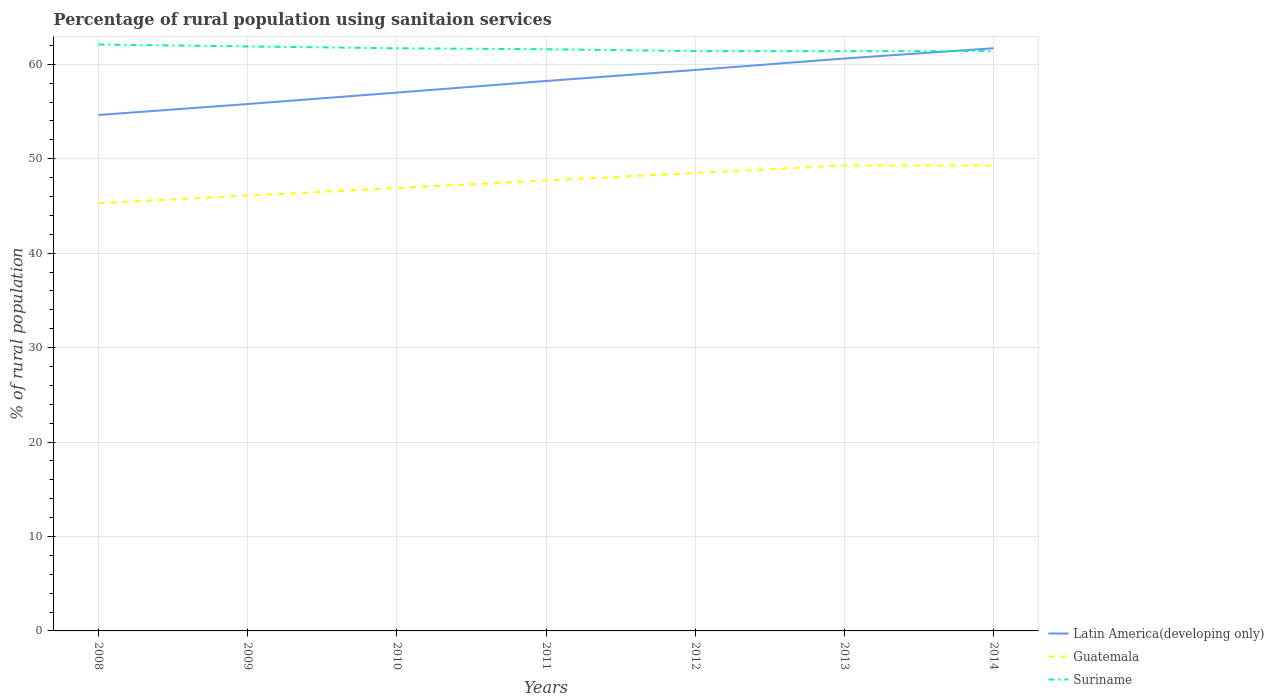How many different coloured lines are there?
Make the answer very short. 3. Does the line corresponding to Guatemala intersect with the line corresponding to Latin America(developing only)?
Offer a terse response. No. Is the number of lines equal to the number of legend labels?
Your response must be concise. Yes. Across all years, what is the maximum percentage of rural population using sanitaion services in Latin America(developing only)?
Offer a very short reply. 54.64. In which year was the percentage of rural population using sanitaion services in Guatemala maximum?
Make the answer very short. 2008. What is the total percentage of rural population using sanitaion services in Latin America(developing only) in the graph?
Make the answer very short. -7.07. What is the difference between the highest and the second highest percentage of rural population using sanitaion services in Suriname?
Provide a succinct answer. 0.7. What is the difference between the highest and the lowest percentage of rural population using sanitaion services in Suriname?
Your response must be concise. 3. Is the percentage of rural population using sanitaion services in Guatemala strictly greater than the percentage of rural population using sanitaion services in Latin America(developing only) over the years?
Your response must be concise. Yes. How many lines are there?
Offer a terse response. 3. How many years are there in the graph?
Make the answer very short. 7. What is the difference between two consecutive major ticks on the Y-axis?
Provide a short and direct response. 10. Does the graph contain any zero values?
Provide a short and direct response. No. Does the graph contain grids?
Make the answer very short. Yes. Where does the legend appear in the graph?
Your response must be concise. Bottom right. What is the title of the graph?
Provide a short and direct response. Percentage of rural population using sanitaion services. What is the label or title of the Y-axis?
Provide a short and direct response. % of rural population. What is the % of rural population of Latin America(developing only) in 2008?
Your answer should be very brief. 54.64. What is the % of rural population of Guatemala in 2008?
Your answer should be very brief. 45.3. What is the % of rural population in Suriname in 2008?
Offer a very short reply. 62.1. What is the % of rural population in Latin America(developing only) in 2009?
Provide a short and direct response. 55.8. What is the % of rural population in Guatemala in 2009?
Make the answer very short. 46.1. What is the % of rural population of Suriname in 2009?
Ensure brevity in your answer.  61.9. What is the % of rural population in Latin America(developing only) in 2010?
Ensure brevity in your answer.  57.01. What is the % of rural population in Guatemala in 2010?
Keep it short and to the point. 46.9. What is the % of rural population in Suriname in 2010?
Ensure brevity in your answer.  61.7. What is the % of rural population in Latin America(developing only) in 2011?
Your answer should be very brief. 58.24. What is the % of rural population of Guatemala in 2011?
Provide a succinct answer. 47.7. What is the % of rural population in Suriname in 2011?
Provide a succinct answer. 61.6. What is the % of rural population of Latin America(developing only) in 2012?
Provide a succinct answer. 59.4. What is the % of rural population of Guatemala in 2012?
Provide a short and direct response. 48.5. What is the % of rural population in Suriname in 2012?
Offer a terse response. 61.4. What is the % of rural population in Latin America(developing only) in 2013?
Keep it short and to the point. 60.62. What is the % of rural population of Guatemala in 2013?
Give a very brief answer. 49.3. What is the % of rural population in Suriname in 2013?
Keep it short and to the point. 61.4. What is the % of rural population in Latin America(developing only) in 2014?
Your answer should be compact. 61.7. What is the % of rural population in Guatemala in 2014?
Your answer should be compact. 49.3. What is the % of rural population of Suriname in 2014?
Your answer should be compact. 61.4. Across all years, what is the maximum % of rural population of Latin America(developing only)?
Provide a short and direct response. 61.7. Across all years, what is the maximum % of rural population in Guatemala?
Your response must be concise. 49.3. Across all years, what is the maximum % of rural population of Suriname?
Your answer should be very brief. 62.1. Across all years, what is the minimum % of rural population of Latin America(developing only)?
Offer a terse response. 54.64. Across all years, what is the minimum % of rural population of Guatemala?
Ensure brevity in your answer.  45.3. Across all years, what is the minimum % of rural population of Suriname?
Keep it short and to the point. 61.4. What is the total % of rural population of Latin America(developing only) in the graph?
Your answer should be very brief. 407.4. What is the total % of rural population in Guatemala in the graph?
Keep it short and to the point. 333.1. What is the total % of rural population in Suriname in the graph?
Offer a terse response. 431.5. What is the difference between the % of rural population of Latin America(developing only) in 2008 and that in 2009?
Ensure brevity in your answer.  -1.16. What is the difference between the % of rural population in Latin America(developing only) in 2008 and that in 2010?
Provide a short and direct response. -2.37. What is the difference between the % of rural population in Suriname in 2008 and that in 2010?
Offer a very short reply. 0.4. What is the difference between the % of rural population of Latin America(developing only) in 2008 and that in 2011?
Your response must be concise. -3.6. What is the difference between the % of rural population of Suriname in 2008 and that in 2011?
Make the answer very short. 0.5. What is the difference between the % of rural population in Latin America(developing only) in 2008 and that in 2012?
Provide a short and direct response. -4.76. What is the difference between the % of rural population of Guatemala in 2008 and that in 2012?
Keep it short and to the point. -3.2. What is the difference between the % of rural population of Latin America(developing only) in 2008 and that in 2013?
Provide a short and direct response. -5.98. What is the difference between the % of rural population of Guatemala in 2008 and that in 2013?
Your response must be concise. -4. What is the difference between the % of rural population of Latin America(developing only) in 2008 and that in 2014?
Provide a succinct answer. -7.07. What is the difference between the % of rural population in Guatemala in 2008 and that in 2014?
Make the answer very short. -4. What is the difference between the % of rural population of Suriname in 2008 and that in 2014?
Offer a terse response. 0.7. What is the difference between the % of rural population of Latin America(developing only) in 2009 and that in 2010?
Offer a very short reply. -1.21. What is the difference between the % of rural population in Latin America(developing only) in 2009 and that in 2011?
Make the answer very short. -2.44. What is the difference between the % of rural population of Guatemala in 2009 and that in 2011?
Your answer should be very brief. -1.6. What is the difference between the % of rural population of Latin America(developing only) in 2009 and that in 2012?
Your answer should be compact. -3.6. What is the difference between the % of rural population in Guatemala in 2009 and that in 2012?
Give a very brief answer. -2.4. What is the difference between the % of rural population of Latin America(developing only) in 2009 and that in 2013?
Your response must be concise. -4.82. What is the difference between the % of rural population in Suriname in 2009 and that in 2013?
Offer a very short reply. 0.5. What is the difference between the % of rural population in Latin America(developing only) in 2009 and that in 2014?
Provide a short and direct response. -5.91. What is the difference between the % of rural population in Guatemala in 2009 and that in 2014?
Keep it short and to the point. -3.2. What is the difference between the % of rural population of Suriname in 2009 and that in 2014?
Ensure brevity in your answer.  0.5. What is the difference between the % of rural population of Latin America(developing only) in 2010 and that in 2011?
Give a very brief answer. -1.23. What is the difference between the % of rural population in Latin America(developing only) in 2010 and that in 2012?
Keep it short and to the point. -2.39. What is the difference between the % of rural population of Latin America(developing only) in 2010 and that in 2013?
Make the answer very short. -3.61. What is the difference between the % of rural population of Suriname in 2010 and that in 2013?
Provide a succinct answer. 0.3. What is the difference between the % of rural population of Latin America(developing only) in 2010 and that in 2014?
Provide a short and direct response. -4.69. What is the difference between the % of rural population in Suriname in 2010 and that in 2014?
Your answer should be very brief. 0.3. What is the difference between the % of rural population in Latin America(developing only) in 2011 and that in 2012?
Provide a short and direct response. -1.16. What is the difference between the % of rural population in Guatemala in 2011 and that in 2012?
Offer a terse response. -0.8. What is the difference between the % of rural population in Suriname in 2011 and that in 2012?
Make the answer very short. 0.2. What is the difference between the % of rural population in Latin America(developing only) in 2011 and that in 2013?
Provide a succinct answer. -2.38. What is the difference between the % of rural population of Suriname in 2011 and that in 2013?
Make the answer very short. 0.2. What is the difference between the % of rural population of Latin America(developing only) in 2011 and that in 2014?
Provide a short and direct response. -3.47. What is the difference between the % of rural population of Latin America(developing only) in 2012 and that in 2013?
Your answer should be compact. -1.22. What is the difference between the % of rural population of Suriname in 2012 and that in 2013?
Offer a very short reply. 0. What is the difference between the % of rural population in Latin America(developing only) in 2012 and that in 2014?
Your response must be concise. -2.3. What is the difference between the % of rural population in Guatemala in 2012 and that in 2014?
Your answer should be very brief. -0.8. What is the difference between the % of rural population of Suriname in 2012 and that in 2014?
Make the answer very short. 0. What is the difference between the % of rural population in Latin America(developing only) in 2013 and that in 2014?
Make the answer very short. -1.08. What is the difference between the % of rural population of Guatemala in 2013 and that in 2014?
Your response must be concise. 0. What is the difference between the % of rural population in Suriname in 2013 and that in 2014?
Ensure brevity in your answer.  0. What is the difference between the % of rural population in Latin America(developing only) in 2008 and the % of rural population in Guatemala in 2009?
Your answer should be compact. 8.54. What is the difference between the % of rural population in Latin America(developing only) in 2008 and the % of rural population in Suriname in 2009?
Offer a very short reply. -7.26. What is the difference between the % of rural population of Guatemala in 2008 and the % of rural population of Suriname in 2009?
Keep it short and to the point. -16.6. What is the difference between the % of rural population in Latin America(developing only) in 2008 and the % of rural population in Guatemala in 2010?
Ensure brevity in your answer.  7.74. What is the difference between the % of rural population in Latin America(developing only) in 2008 and the % of rural population in Suriname in 2010?
Your answer should be very brief. -7.06. What is the difference between the % of rural population of Guatemala in 2008 and the % of rural population of Suriname in 2010?
Ensure brevity in your answer.  -16.4. What is the difference between the % of rural population of Latin America(developing only) in 2008 and the % of rural population of Guatemala in 2011?
Make the answer very short. 6.94. What is the difference between the % of rural population in Latin America(developing only) in 2008 and the % of rural population in Suriname in 2011?
Offer a very short reply. -6.96. What is the difference between the % of rural population of Guatemala in 2008 and the % of rural population of Suriname in 2011?
Make the answer very short. -16.3. What is the difference between the % of rural population of Latin America(developing only) in 2008 and the % of rural population of Guatemala in 2012?
Offer a terse response. 6.14. What is the difference between the % of rural population in Latin America(developing only) in 2008 and the % of rural population in Suriname in 2012?
Offer a very short reply. -6.76. What is the difference between the % of rural population of Guatemala in 2008 and the % of rural population of Suriname in 2012?
Offer a terse response. -16.1. What is the difference between the % of rural population in Latin America(developing only) in 2008 and the % of rural population in Guatemala in 2013?
Make the answer very short. 5.34. What is the difference between the % of rural population in Latin America(developing only) in 2008 and the % of rural population in Suriname in 2013?
Make the answer very short. -6.76. What is the difference between the % of rural population of Guatemala in 2008 and the % of rural population of Suriname in 2013?
Provide a succinct answer. -16.1. What is the difference between the % of rural population in Latin America(developing only) in 2008 and the % of rural population in Guatemala in 2014?
Your answer should be very brief. 5.34. What is the difference between the % of rural population in Latin America(developing only) in 2008 and the % of rural population in Suriname in 2014?
Your response must be concise. -6.76. What is the difference between the % of rural population of Guatemala in 2008 and the % of rural population of Suriname in 2014?
Keep it short and to the point. -16.1. What is the difference between the % of rural population in Latin America(developing only) in 2009 and the % of rural population in Guatemala in 2010?
Make the answer very short. 8.9. What is the difference between the % of rural population of Latin America(developing only) in 2009 and the % of rural population of Suriname in 2010?
Provide a succinct answer. -5.9. What is the difference between the % of rural population of Guatemala in 2009 and the % of rural population of Suriname in 2010?
Provide a succinct answer. -15.6. What is the difference between the % of rural population in Latin America(developing only) in 2009 and the % of rural population in Guatemala in 2011?
Make the answer very short. 8.1. What is the difference between the % of rural population in Latin America(developing only) in 2009 and the % of rural population in Suriname in 2011?
Your response must be concise. -5.8. What is the difference between the % of rural population in Guatemala in 2009 and the % of rural population in Suriname in 2011?
Keep it short and to the point. -15.5. What is the difference between the % of rural population in Latin America(developing only) in 2009 and the % of rural population in Guatemala in 2012?
Offer a very short reply. 7.3. What is the difference between the % of rural population in Latin America(developing only) in 2009 and the % of rural population in Suriname in 2012?
Offer a terse response. -5.6. What is the difference between the % of rural population in Guatemala in 2009 and the % of rural population in Suriname in 2012?
Give a very brief answer. -15.3. What is the difference between the % of rural population in Latin America(developing only) in 2009 and the % of rural population in Guatemala in 2013?
Your answer should be very brief. 6.5. What is the difference between the % of rural population of Latin America(developing only) in 2009 and the % of rural population of Suriname in 2013?
Keep it short and to the point. -5.6. What is the difference between the % of rural population of Guatemala in 2009 and the % of rural population of Suriname in 2013?
Ensure brevity in your answer.  -15.3. What is the difference between the % of rural population of Latin America(developing only) in 2009 and the % of rural population of Guatemala in 2014?
Ensure brevity in your answer.  6.5. What is the difference between the % of rural population in Latin America(developing only) in 2009 and the % of rural population in Suriname in 2014?
Provide a succinct answer. -5.6. What is the difference between the % of rural population of Guatemala in 2009 and the % of rural population of Suriname in 2014?
Provide a succinct answer. -15.3. What is the difference between the % of rural population of Latin America(developing only) in 2010 and the % of rural population of Guatemala in 2011?
Provide a succinct answer. 9.31. What is the difference between the % of rural population in Latin America(developing only) in 2010 and the % of rural population in Suriname in 2011?
Provide a succinct answer. -4.59. What is the difference between the % of rural population of Guatemala in 2010 and the % of rural population of Suriname in 2011?
Your response must be concise. -14.7. What is the difference between the % of rural population of Latin America(developing only) in 2010 and the % of rural population of Guatemala in 2012?
Your answer should be very brief. 8.51. What is the difference between the % of rural population in Latin America(developing only) in 2010 and the % of rural population in Suriname in 2012?
Give a very brief answer. -4.39. What is the difference between the % of rural population of Latin America(developing only) in 2010 and the % of rural population of Guatemala in 2013?
Offer a terse response. 7.71. What is the difference between the % of rural population of Latin America(developing only) in 2010 and the % of rural population of Suriname in 2013?
Your response must be concise. -4.39. What is the difference between the % of rural population of Guatemala in 2010 and the % of rural population of Suriname in 2013?
Give a very brief answer. -14.5. What is the difference between the % of rural population in Latin America(developing only) in 2010 and the % of rural population in Guatemala in 2014?
Ensure brevity in your answer.  7.71. What is the difference between the % of rural population of Latin America(developing only) in 2010 and the % of rural population of Suriname in 2014?
Your answer should be compact. -4.39. What is the difference between the % of rural population in Latin America(developing only) in 2011 and the % of rural population in Guatemala in 2012?
Your answer should be very brief. 9.74. What is the difference between the % of rural population in Latin America(developing only) in 2011 and the % of rural population in Suriname in 2012?
Provide a succinct answer. -3.16. What is the difference between the % of rural population in Guatemala in 2011 and the % of rural population in Suriname in 2012?
Keep it short and to the point. -13.7. What is the difference between the % of rural population of Latin America(developing only) in 2011 and the % of rural population of Guatemala in 2013?
Provide a succinct answer. 8.94. What is the difference between the % of rural population in Latin America(developing only) in 2011 and the % of rural population in Suriname in 2013?
Provide a short and direct response. -3.16. What is the difference between the % of rural population of Guatemala in 2011 and the % of rural population of Suriname in 2013?
Your answer should be compact. -13.7. What is the difference between the % of rural population in Latin America(developing only) in 2011 and the % of rural population in Guatemala in 2014?
Your answer should be compact. 8.94. What is the difference between the % of rural population of Latin America(developing only) in 2011 and the % of rural population of Suriname in 2014?
Your answer should be very brief. -3.16. What is the difference between the % of rural population in Guatemala in 2011 and the % of rural population in Suriname in 2014?
Provide a short and direct response. -13.7. What is the difference between the % of rural population of Latin America(developing only) in 2012 and the % of rural population of Guatemala in 2013?
Make the answer very short. 10.1. What is the difference between the % of rural population in Latin America(developing only) in 2012 and the % of rural population in Suriname in 2013?
Provide a succinct answer. -2. What is the difference between the % of rural population in Guatemala in 2012 and the % of rural population in Suriname in 2013?
Your answer should be very brief. -12.9. What is the difference between the % of rural population in Latin America(developing only) in 2012 and the % of rural population in Guatemala in 2014?
Your response must be concise. 10.1. What is the difference between the % of rural population of Latin America(developing only) in 2012 and the % of rural population of Suriname in 2014?
Provide a succinct answer. -2. What is the difference between the % of rural population of Guatemala in 2012 and the % of rural population of Suriname in 2014?
Offer a very short reply. -12.9. What is the difference between the % of rural population in Latin America(developing only) in 2013 and the % of rural population in Guatemala in 2014?
Offer a terse response. 11.32. What is the difference between the % of rural population in Latin America(developing only) in 2013 and the % of rural population in Suriname in 2014?
Keep it short and to the point. -0.78. What is the difference between the % of rural population in Guatemala in 2013 and the % of rural population in Suriname in 2014?
Provide a short and direct response. -12.1. What is the average % of rural population in Latin America(developing only) per year?
Provide a short and direct response. 58.2. What is the average % of rural population of Guatemala per year?
Make the answer very short. 47.59. What is the average % of rural population of Suriname per year?
Provide a succinct answer. 61.64. In the year 2008, what is the difference between the % of rural population of Latin America(developing only) and % of rural population of Guatemala?
Give a very brief answer. 9.34. In the year 2008, what is the difference between the % of rural population in Latin America(developing only) and % of rural population in Suriname?
Give a very brief answer. -7.46. In the year 2008, what is the difference between the % of rural population of Guatemala and % of rural population of Suriname?
Your response must be concise. -16.8. In the year 2009, what is the difference between the % of rural population in Latin America(developing only) and % of rural population in Guatemala?
Make the answer very short. 9.7. In the year 2009, what is the difference between the % of rural population of Latin America(developing only) and % of rural population of Suriname?
Offer a very short reply. -6.1. In the year 2009, what is the difference between the % of rural population of Guatemala and % of rural population of Suriname?
Offer a terse response. -15.8. In the year 2010, what is the difference between the % of rural population in Latin America(developing only) and % of rural population in Guatemala?
Provide a succinct answer. 10.11. In the year 2010, what is the difference between the % of rural population in Latin America(developing only) and % of rural population in Suriname?
Your answer should be very brief. -4.69. In the year 2010, what is the difference between the % of rural population in Guatemala and % of rural population in Suriname?
Keep it short and to the point. -14.8. In the year 2011, what is the difference between the % of rural population of Latin America(developing only) and % of rural population of Guatemala?
Make the answer very short. 10.54. In the year 2011, what is the difference between the % of rural population of Latin America(developing only) and % of rural population of Suriname?
Your response must be concise. -3.36. In the year 2011, what is the difference between the % of rural population in Guatemala and % of rural population in Suriname?
Your answer should be very brief. -13.9. In the year 2012, what is the difference between the % of rural population of Latin America(developing only) and % of rural population of Guatemala?
Make the answer very short. 10.9. In the year 2012, what is the difference between the % of rural population of Latin America(developing only) and % of rural population of Suriname?
Provide a succinct answer. -2. In the year 2013, what is the difference between the % of rural population of Latin America(developing only) and % of rural population of Guatemala?
Provide a short and direct response. 11.32. In the year 2013, what is the difference between the % of rural population of Latin America(developing only) and % of rural population of Suriname?
Your response must be concise. -0.78. In the year 2013, what is the difference between the % of rural population of Guatemala and % of rural population of Suriname?
Make the answer very short. -12.1. In the year 2014, what is the difference between the % of rural population in Latin America(developing only) and % of rural population in Guatemala?
Provide a succinct answer. 12.4. In the year 2014, what is the difference between the % of rural population in Latin America(developing only) and % of rural population in Suriname?
Offer a terse response. 0.3. In the year 2014, what is the difference between the % of rural population of Guatemala and % of rural population of Suriname?
Ensure brevity in your answer.  -12.1. What is the ratio of the % of rural population in Latin America(developing only) in 2008 to that in 2009?
Your answer should be compact. 0.98. What is the ratio of the % of rural population of Guatemala in 2008 to that in 2009?
Ensure brevity in your answer.  0.98. What is the ratio of the % of rural population of Suriname in 2008 to that in 2009?
Provide a short and direct response. 1. What is the ratio of the % of rural population of Latin America(developing only) in 2008 to that in 2010?
Ensure brevity in your answer.  0.96. What is the ratio of the % of rural population in Guatemala in 2008 to that in 2010?
Provide a succinct answer. 0.97. What is the ratio of the % of rural population in Suriname in 2008 to that in 2010?
Ensure brevity in your answer.  1.01. What is the ratio of the % of rural population in Latin America(developing only) in 2008 to that in 2011?
Your response must be concise. 0.94. What is the ratio of the % of rural population of Guatemala in 2008 to that in 2011?
Your answer should be very brief. 0.95. What is the ratio of the % of rural population in Suriname in 2008 to that in 2011?
Your answer should be compact. 1.01. What is the ratio of the % of rural population of Latin America(developing only) in 2008 to that in 2012?
Your response must be concise. 0.92. What is the ratio of the % of rural population in Guatemala in 2008 to that in 2012?
Keep it short and to the point. 0.93. What is the ratio of the % of rural population in Suriname in 2008 to that in 2012?
Offer a terse response. 1.01. What is the ratio of the % of rural population of Latin America(developing only) in 2008 to that in 2013?
Keep it short and to the point. 0.9. What is the ratio of the % of rural population of Guatemala in 2008 to that in 2013?
Make the answer very short. 0.92. What is the ratio of the % of rural population in Suriname in 2008 to that in 2013?
Keep it short and to the point. 1.01. What is the ratio of the % of rural population of Latin America(developing only) in 2008 to that in 2014?
Offer a very short reply. 0.89. What is the ratio of the % of rural population in Guatemala in 2008 to that in 2014?
Provide a succinct answer. 0.92. What is the ratio of the % of rural population in Suriname in 2008 to that in 2014?
Offer a terse response. 1.01. What is the ratio of the % of rural population of Latin America(developing only) in 2009 to that in 2010?
Offer a terse response. 0.98. What is the ratio of the % of rural population of Guatemala in 2009 to that in 2010?
Give a very brief answer. 0.98. What is the ratio of the % of rural population of Latin America(developing only) in 2009 to that in 2011?
Provide a short and direct response. 0.96. What is the ratio of the % of rural population in Guatemala in 2009 to that in 2011?
Give a very brief answer. 0.97. What is the ratio of the % of rural population in Latin America(developing only) in 2009 to that in 2012?
Provide a succinct answer. 0.94. What is the ratio of the % of rural population in Guatemala in 2009 to that in 2012?
Your response must be concise. 0.95. What is the ratio of the % of rural population of Suriname in 2009 to that in 2012?
Your answer should be very brief. 1.01. What is the ratio of the % of rural population of Latin America(developing only) in 2009 to that in 2013?
Offer a terse response. 0.92. What is the ratio of the % of rural population in Guatemala in 2009 to that in 2013?
Give a very brief answer. 0.94. What is the ratio of the % of rural population of Latin America(developing only) in 2009 to that in 2014?
Provide a succinct answer. 0.9. What is the ratio of the % of rural population of Guatemala in 2009 to that in 2014?
Your answer should be very brief. 0.94. What is the ratio of the % of rural population of Latin America(developing only) in 2010 to that in 2011?
Your answer should be very brief. 0.98. What is the ratio of the % of rural population in Guatemala in 2010 to that in 2011?
Keep it short and to the point. 0.98. What is the ratio of the % of rural population of Latin America(developing only) in 2010 to that in 2012?
Offer a very short reply. 0.96. What is the ratio of the % of rural population of Suriname in 2010 to that in 2012?
Offer a very short reply. 1. What is the ratio of the % of rural population of Latin America(developing only) in 2010 to that in 2013?
Offer a very short reply. 0.94. What is the ratio of the % of rural population in Guatemala in 2010 to that in 2013?
Your answer should be compact. 0.95. What is the ratio of the % of rural population of Latin America(developing only) in 2010 to that in 2014?
Give a very brief answer. 0.92. What is the ratio of the % of rural population of Guatemala in 2010 to that in 2014?
Your answer should be compact. 0.95. What is the ratio of the % of rural population of Suriname in 2010 to that in 2014?
Keep it short and to the point. 1. What is the ratio of the % of rural population of Latin America(developing only) in 2011 to that in 2012?
Provide a succinct answer. 0.98. What is the ratio of the % of rural population of Guatemala in 2011 to that in 2012?
Provide a short and direct response. 0.98. What is the ratio of the % of rural population of Suriname in 2011 to that in 2012?
Keep it short and to the point. 1. What is the ratio of the % of rural population of Latin America(developing only) in 2011 to that in 2013?
Your response must be concise. 0.96. What is the ratio of the % of rural population in Guatemala in 2011 to that in 2013?
Your answer should be very brief. 0.97. What is the ratio of the % of rural population in Suriname in 2011 to that in 2013?
Your response must be concise. 1. What is the ratio of the % of rural population of Latin America(developing only) in 2011 to that in 2014?
Make the answer very short. 0.94. What is the ratio of the % of rural population of Guatemala in 2011 to that in 2014?
Your answer should be very brief. 0.97. What is the ratio of the % of rural population of Latin America(developing only) in 2012 to that in 2013?
Make the answer very short. 0.98. What is the ratio of the % of rural population of Guatemala in 2012 to that in 2013?
Give a very brief answer. 0.98. What is the ratio of the % of rural population in Suriname in 2012 to that in 2013?
Give a very brief answer. 1. What is the ratio of the % of rural population of Latin America(developing only) in 2012 to that in 2014?
Offer a very short reply. 0.96. What is the ratio of the % of rural population of Guatemala in 2012 to that in 2014?
Ensure brevity in your answer.  0.98. What is the ratio of the % of rural population in Suriname in 2012 to that in 2014?
Your answer should be compact. 1. What is the ratio of the % of rural population in Latin America(developing only) in 2013 to that in 2014?
Give a very brief answer. 0.98. What is the ratio of the % of rural population in Suriname in 2013 to that in 2014?
Offer a terse response. 1. What is the difference between the highest and the second highest % of rural population in Latin America(developing only)?
Provide a succinct answer. 1.08. What is the difference between the highest and the lowest % of rural population in Latin America(developing only)?
Ensure brevity in your answer.  7.07. 